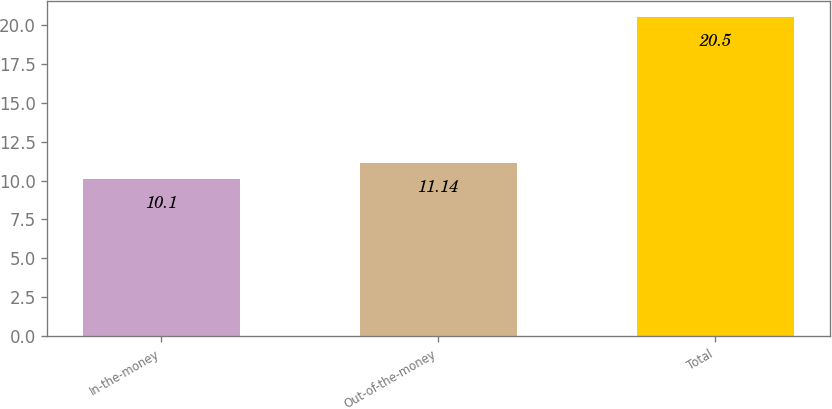<chart> <loc_0><loc_0><loc_500><loc_500><bar_chart><fcel>In-the-money<fcel>Out-of-the-money<fcel>Total<nl><fcel>10.1<fcel>11.14<fcel>20.5<nl></chart> 